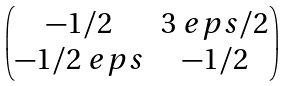<formula> <loc_0><loc_0><loc_500><loc_500>\begin{pmatrix} - 1 / 2 & 3 \ e p s / 2 \\ - 1 / 2 \ e p s & - 1 / 2 \end{pmatrix}</formula> 